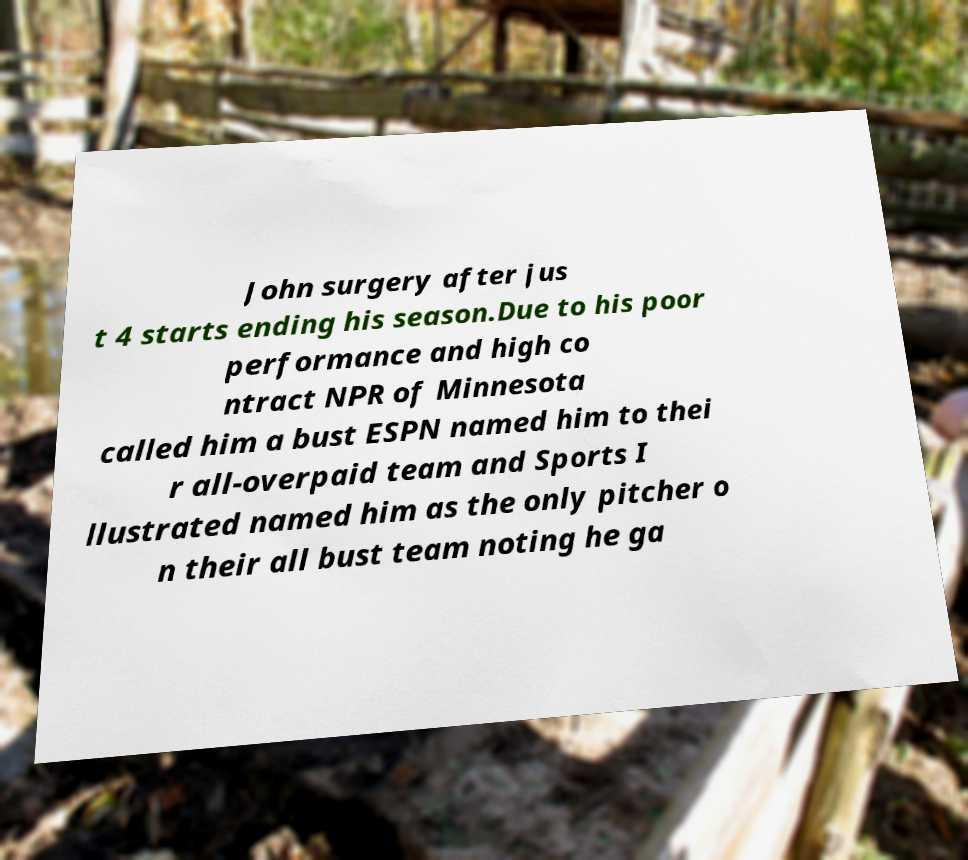What messages or text are displayed in this image? I need them in a readable, typed format. John surgery after jus t 4 starts ending his season.Due to his poor performance and high co ntract NPR of Minnesota called him a bust ESPN named him to thei r all-overpaid team and Sports I llustrated named him as the only pitcher o n their all bust team noting he ga 